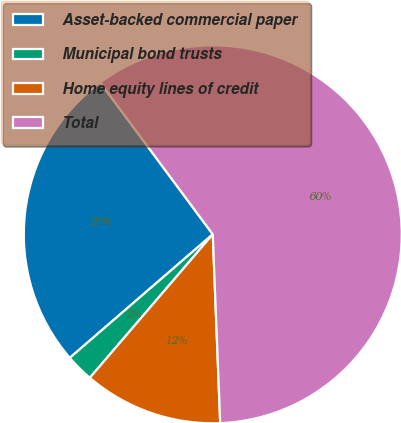Convert chart. <chart><loc_0><loc_0><loc_500><loc_500><pie_chart><fcel>Asset-backed commercial paper<fcel>Municipal bond trusts<fcel>Home equity lines of credit<fcel>Total<nl><fcel>26.19%<fcel>2.38%<fcel>11.9%<fcel>59.52%<nl></chart> 